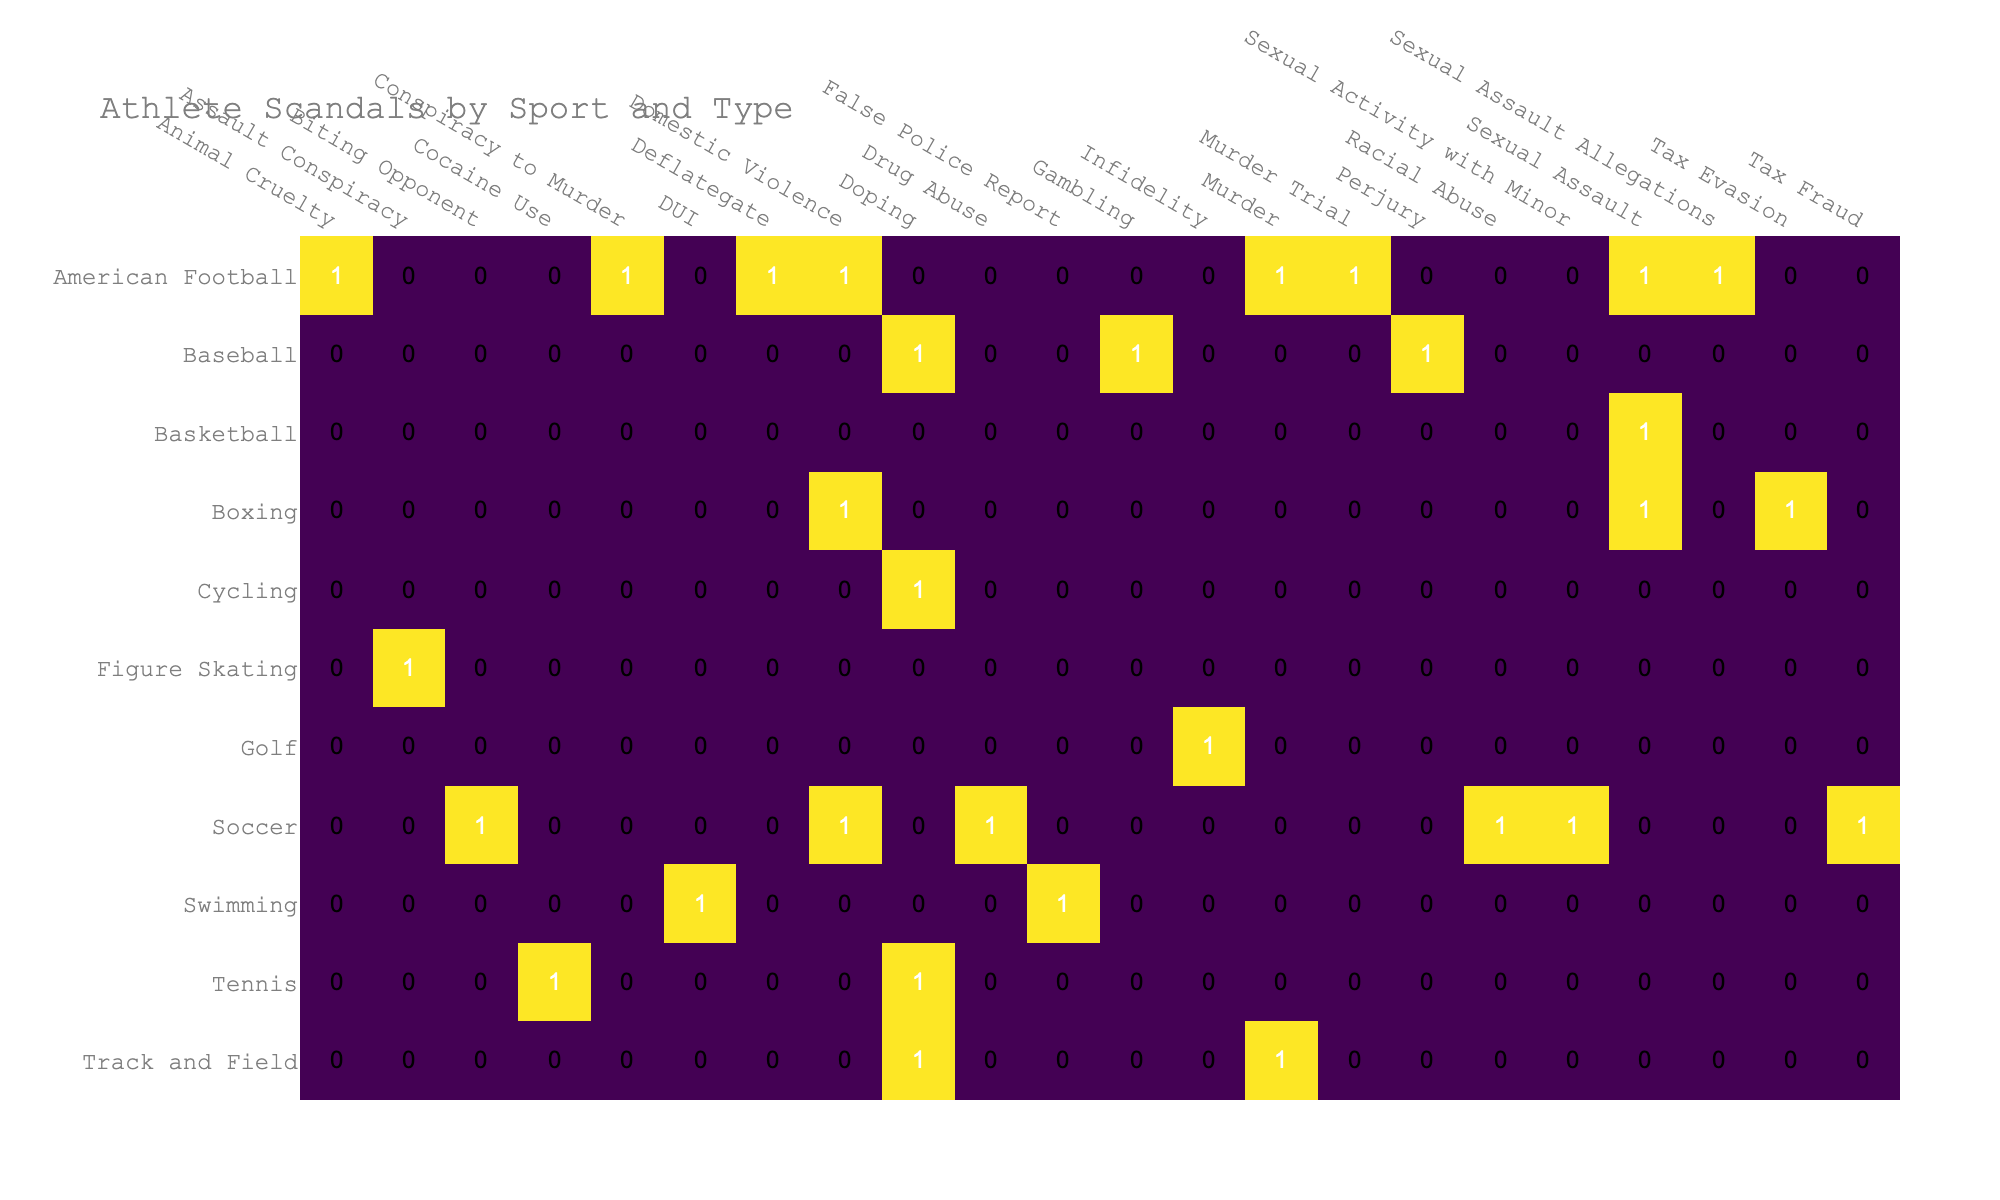What is the total number of doping scandals in sports? By checking the table under the column for "Doping," we can identify the sports listed: Cycling, Swimming, Tennis, Track and Field, and Baseball with a count of 1 in each. Thus, the total is 5.
Answer: 5 Which sport has the highest number of scandals? By examining the table, Soccer has 5 scandals listed, which is more than any other sport.
Answer: Soccer Are there more severe scandals in American Football or Boxing? The table shows that American Football has 4 severe scandals (Animal Cruelty, Murder, Sexual Assault, and Conspiracy to Murder), while Boxing has 2 severe scandals (Sexual Assault and Domestic Violence). Therefore, American Football has more severe scandals.
Answer: Yes How many different types of scandals are there in Tennis? The table shows 2 types of scandals in Tennis: Doping and Cocaine Use.
Answer: 2 Which athlete is involved in domestic violence scandals, and how many such incidents are there? The table lists Floyd Mayweather Jr. and Ray Rice with different counts for Domestic Violence: Floyd Mayweather Jr. has 1 and Ray Rice has 1 as well, giving a total of 2 domestic violence incidents.
Answer: 2 In the scandal types, is there a "Biting Opponent" incident? The table shows that "Biting Opponent" is a listed scandal type under the sport of Soccer and is attributed to Luis Suarez.
Answer: Yes Which sport has the highest impact level scandal, and what is that scandal? Upon reviewing the table, Track and Field has a severe scandal involving Oscar Pistorius for Murder, which is the highest impact scandal among all sports listed.
Answer: Track and Field: Murder What is the average impact level of scandals in Soccer? In the table, Soccer has 5 incidents with impact levels: 1 High, 1 Medium, 1 High, 1 Medium, and 1 Medium. For scoring purposes: High = 3, Medium = 2, so the total is (3 + 2 + 3 + 2 + 2) = 12 for 5 incidents. The average is 12/5 = 2.4.
Answer: 2.4 